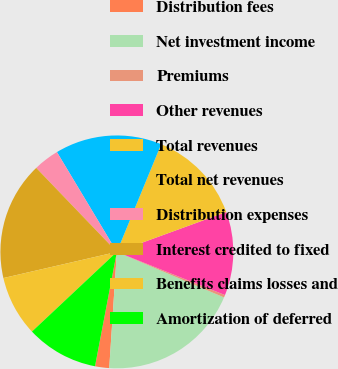Convert chart to OTSL. <chart><loc_0><loc_0><loc_500><loc_500><pie_chart><fcel>Distribution fees<fcel>Net investment income<fcel>Premiums<fcel>Other revenues<fcel>Total revenues<fcel>Total net revenues<fcel>Distribution expenses<fcel>Interest credited to fixed<fcel>Benefits claims losses and<fcel>Amortization of deferred<nl><fcel>1.96%<fcel>19.65%<fcel>0.35%<fcel>11.61%<fcel>13.22%<fcel>14.82%<fcel>3.57%<fcel>16.43%<fcel>8.39%<fcel>10.0%<nl></chart> 